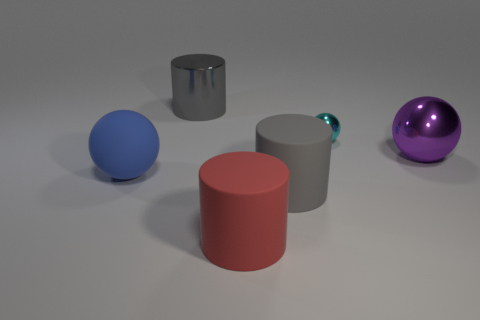Subtract all gray cylinders. How many were subtracted if there are1gray cylinders left? 1 Subtract all purple spheres. Subtract all gray cylinders. How many spheres are left? 2 Add 3 red matte objects. How many objects exist? 9 Subtract all large gray cylinders. Subtract all large red matte things. How many objects are left? 3 Add 5 metal balls. How many metal balls are left? 7 Add 6 large cylinders. How many large cylinders exist? 9 Subtract 1 red cylinders. How many objects are left? 5 